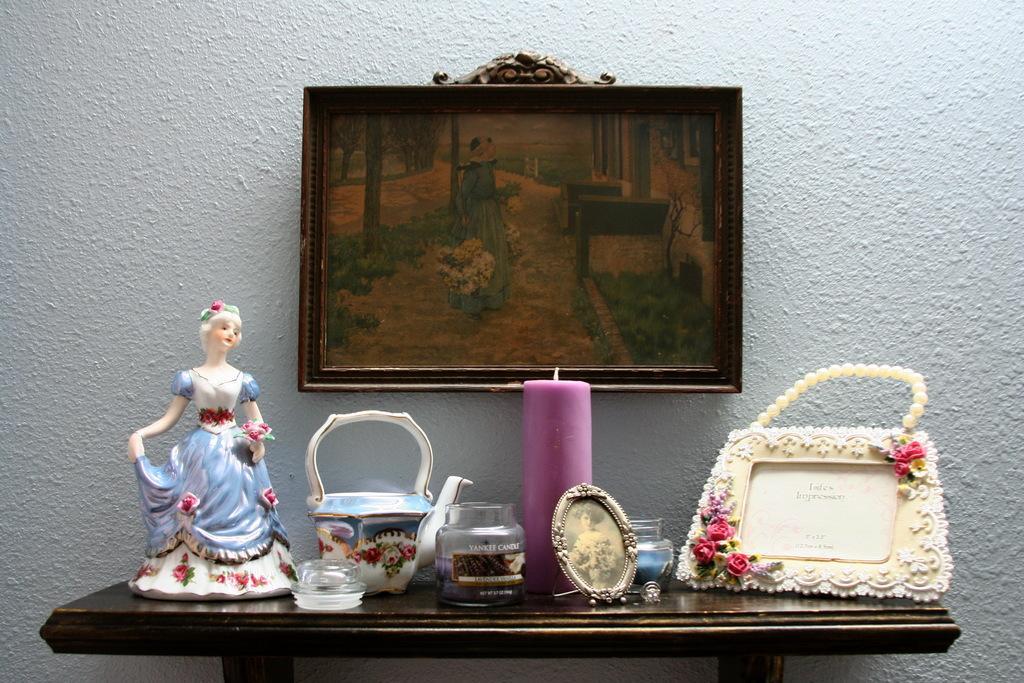Describe this image in one or two sentences. In this picture there is a table with some dolls and cattle and candle placed on it there is a photo frame on the wall 